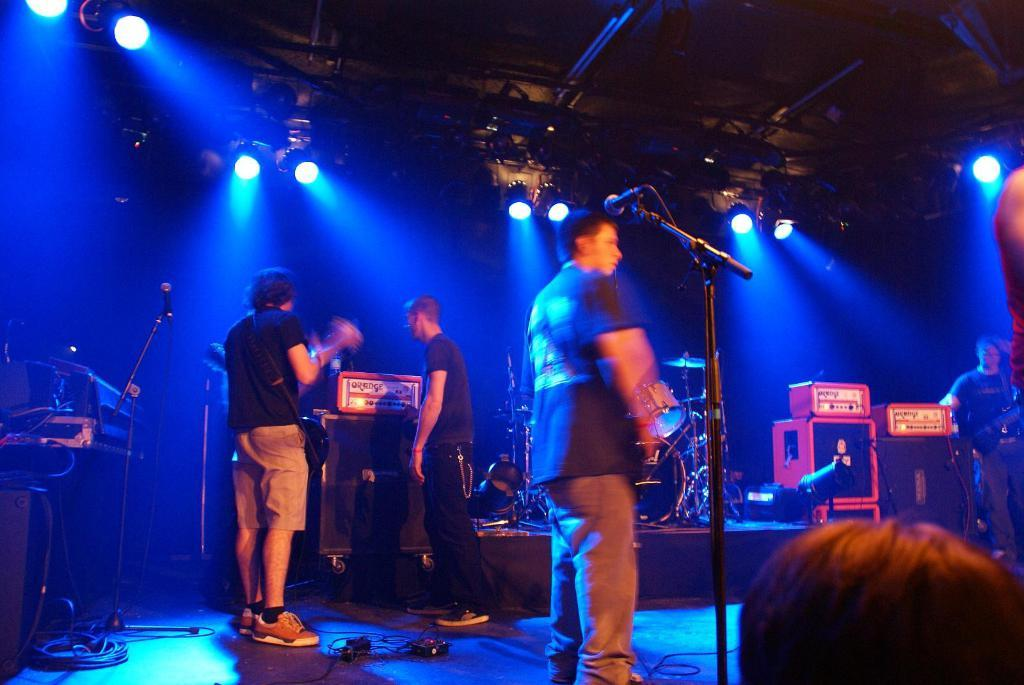What are the persons in the image doing? The persons in the image are standing and playing musical instruments. What objects are present in the image that are related to sound production? There are sound boxes and microphones in the image. What can be seen at the top of the image? There are lights visible at the top of the image. What structure is present above the persons and instruments in the image? There is a roof in the image. What type of receipt can be seen in the image? There is no receipt present in the image. What is the level of friction between the persons and their instruments in the image? The level of friction between the persons and their instruments cannot be determined from the image. 